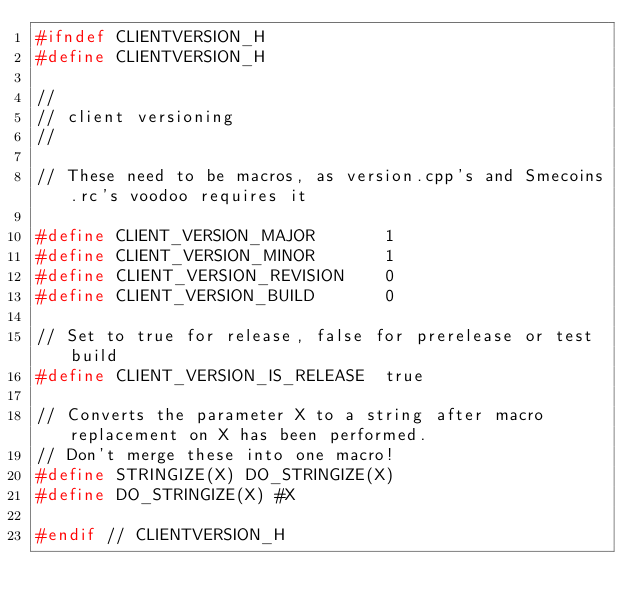<code> <loc_0><loc_0><loc_500><loc_500><_C_>#ifndef CLIENTVERSION_H
#define CLIENTVERSION_H

//
// client versioning
//

// These need to be macros, as version.cpp's and Smecoins.rc's voodoo requires it

#define CLIENT_VERSION_MAJOR       1
#define CLIENT_VERSION_MINOR       1
#define CLIENT_VERSION_REVISION    0
#define CLIENT_VERSION_BUILD       0

// Set to true for release, false for prerelease or test build
#define CLIENT_VERSION_IS_RELEASE  true

// Converts the parameter X to a string after macro replacement on X has been performed.
// Don't merge these into one macro!
#define STRINGIZE(X) DO_STRINGIZE(X)
#define DO_STRINGIZE(X) #X

#endif // CLIENTVERSION_H
</code> 